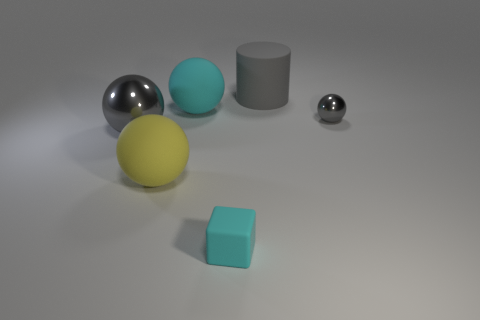Subtract all large spheres. How many spheres are left? 1 Add 1 cyan matte things. How many objects exist? 7 Subtract all cyan balls. How many balls are left? 3 Subtract all spheres. How many objects are left? 2 Subtract 1 cubes. How many cubes are left? 0 Subtract all cyan cubes. How many gray balls are left? 2 Subtract all large gray objects. Subtract all small gray metallic things. How many objects are left? 3 Add 1 spheres. How many spheres are left? 5 Add 4 gray cylinders. How many gray cylinders exist? 5 Subtract 0 red balls. How many objects are left? 6 